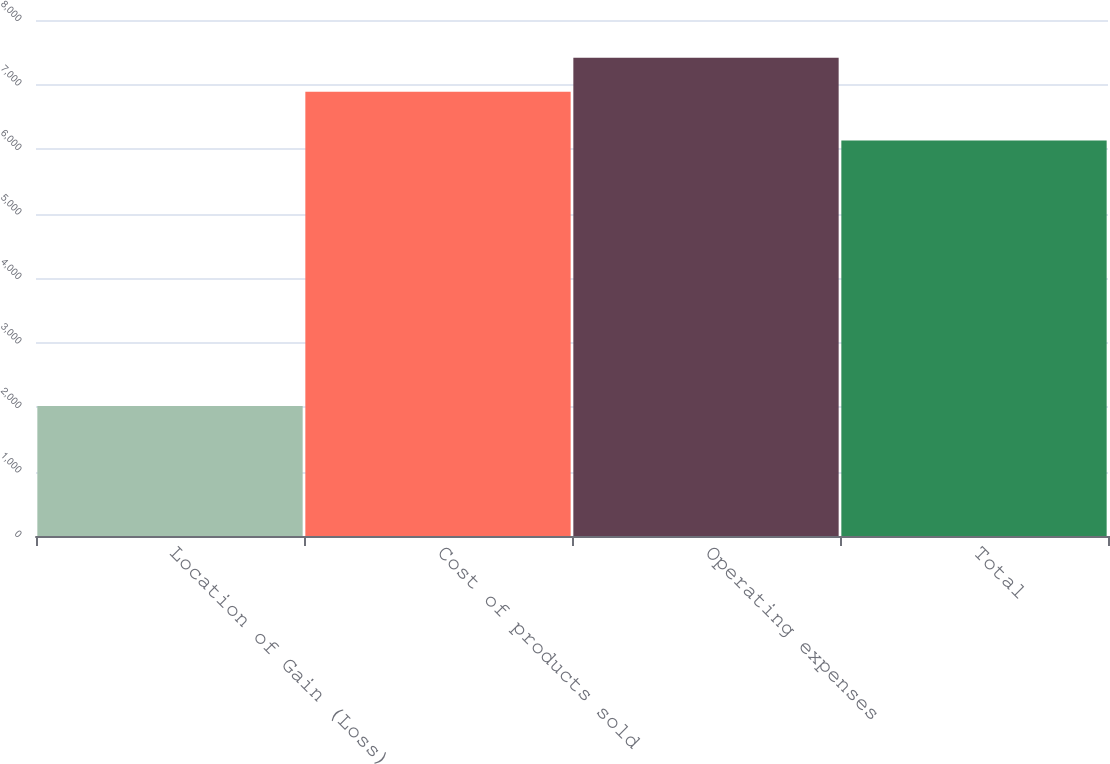<chart> <loc_0><loc_0><loc_500><loc_500><bar_chart><fcel>Location of Gain (Loss)<fcel>Cost of products sold<fcel>Operating expenses<fcel>Total<nl><fcel>2016<fcel>6889<fcel>7415<fcel>6133<nl></chart> 